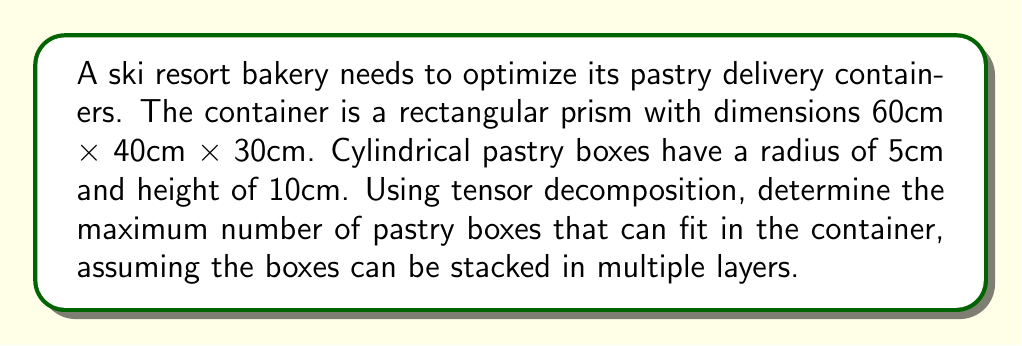Solve this math problem. To solve this problem using tensor decomposition, we'll follow these steps:

1) First, let's represent the container as a 3rd-order tensor $\mathcal{A} \in \mathbb{R}^{60 \times 40 \times 30}$, where each entry represents a 1cm³ cube.

2) We can decompose this tensor into rank-1 components using CP decomposition:

   $$\mathcal{A} \approx \sum_{r=1}^R a_r \circ b_r \circ c_r$$

   where $a_r$, $b_r$, and $c_r$ are vectors representing the dimensions of the container.

3) Each pastry box can be represented as a rank-1 tensor:

   $$\mathcal{P} = p \circ q \circ h$$

   where $p$ and $q$ are vectors of length 10 (diameter) and $h$ is a vector of length 10 (height).

4) The number of pastry boxes that can fit along each dimension is:

   Length: $\lfloor 60 / 10 \rfloor = 6$
   Width: $\lfloor 40 / 10 \rfloor = 4$
   Height: $\lfloor 30 / 10 \rfloor = 3$

5) The total number of pastry boxes is the product of these values:

   $6 \times 4 \times 3 = 72$

6) This arrangement can be represented as a sum of 72 rank-1 tensors:

   $$\mathcal{B} = \sum_{i=1}^{72} p_i \circ q_i \circ h_i$$

   where each $(p_i, q_i, h_i)$ represents the position and orientation of a pastry box.

7) The optimal packing is achieved when:

   $$\mathcal{A} \approx \mathcal{B}$$

   minimizing the difference between the container tensor and the sum of pastry box tensors.
Answer: 72 pastry boxes 